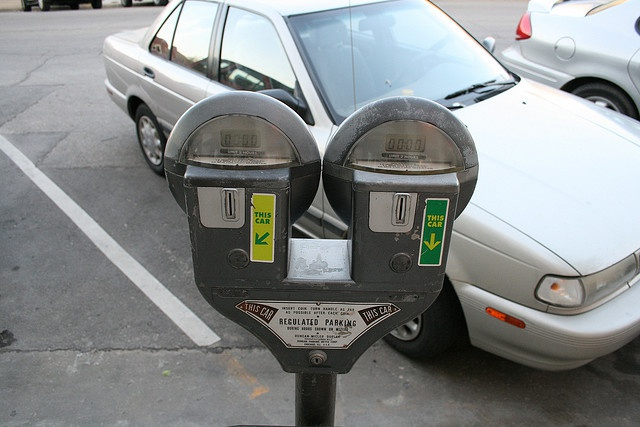Describe the objects in this image and their specific colors. I can see car in darkgray, white, gray, and lightblue tones, parking meter in darkgray, black, gray, and darkgreen tones, parking meter in darkgray, black, gray, and olive tones, car in darkgray, white, black, and lightgray tones, and car in darkgray, black, gray, and darkgreen tones in this image. 